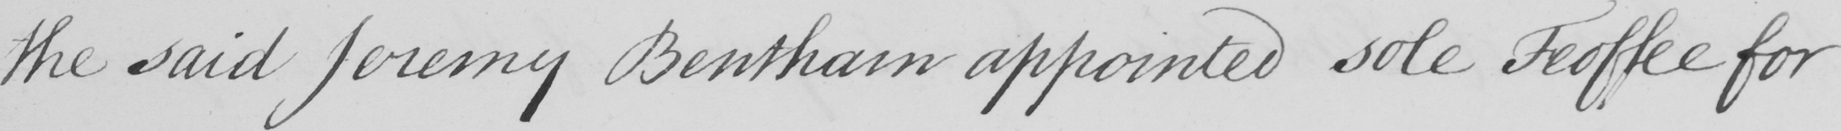What is written in this line of handwriting? the said Jeremy Bentham appointed sole Feoffee for 